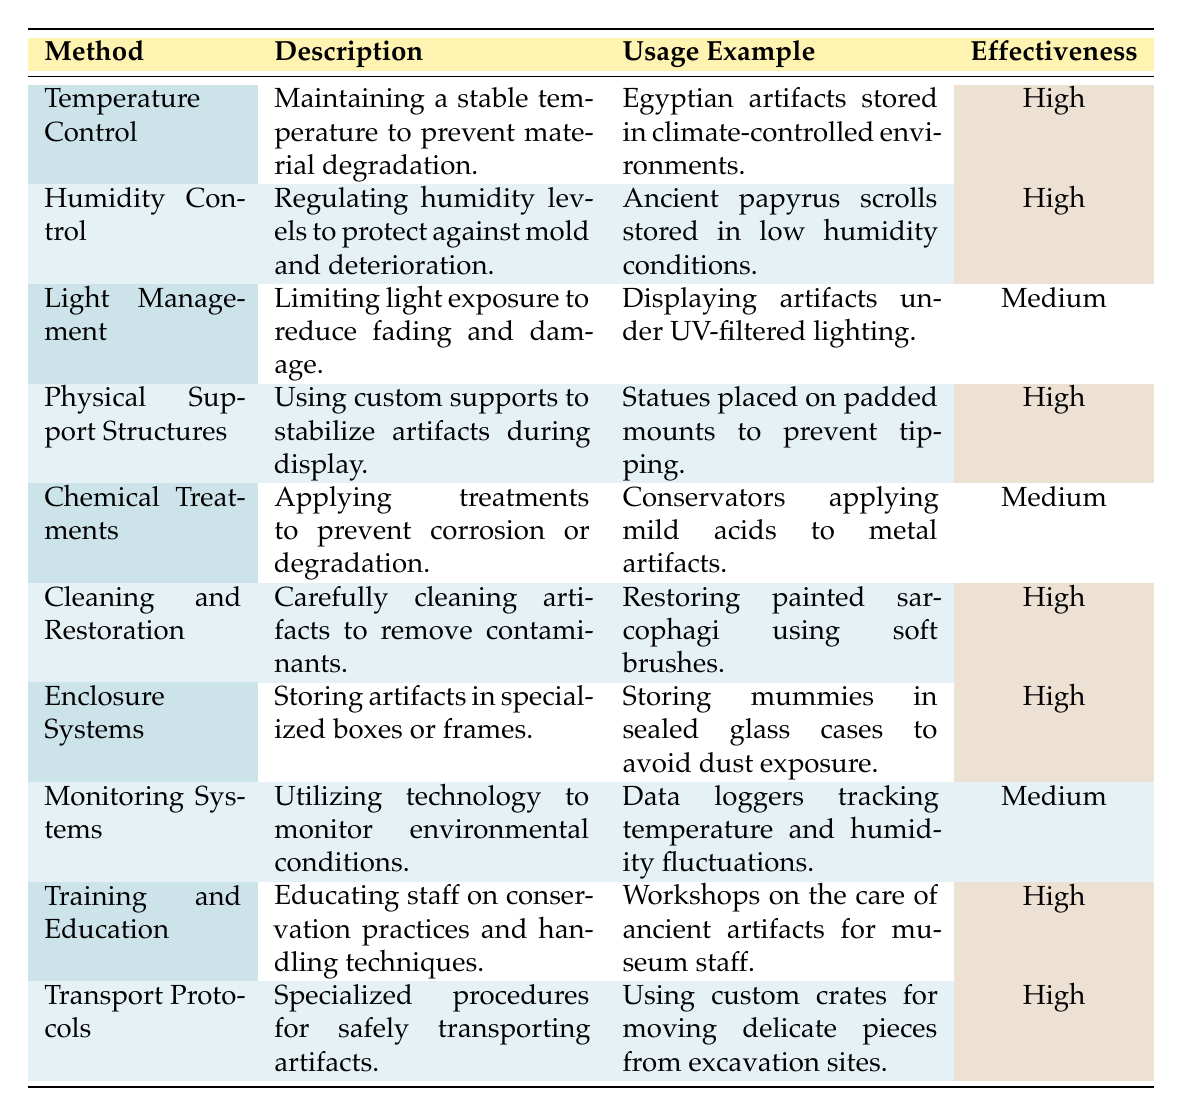What is the usage example for Temperature Control? The table lists the usage example for Temperature Control as "Egyptian artifacts stored in climate-controlled environments." This is directly referenced in the second column of the corresponding row.
Answer: Egyptian artifacts stored in climate-controlled environments Which artifact preservation method has a medium effectiveness rating? Upon reviewing the table, we can see that both "Light Management" and "Chemical Treatments" have an effectiveness rating of Medium, as indicated in the last column.
Answer: Light Management and Chemical Treatments How many preservation methods are listed with a High effectiveness rating? There are six methods marked as High in the effectiveness column: Temperature Control, Humidity Control, Physical Support Structures, Cleaning and Restoration, Enclosure Systems, and Training and Education. Counting these gives us a total of six methods.
Answer: 6 Is it true that all preservation methods utilize technology? Checking the table, it is clear that only the "Monitoring Systems" method explicitly utilizes technology to monitor environmental conditions. Therefore, the statement is false as other methods do not involve technological aspects.
Answer: No What is the difference in effectiveness between the methods with the highest and lowest ratings? The methods with the highest effectiveness rating (High) include six methods while those rated Medium are two. The effectiveness metric is qualitative, and counting them reveals that High has six and Medium has two. Thus, the difference is four methods that are rated higher.
Answer: 4 